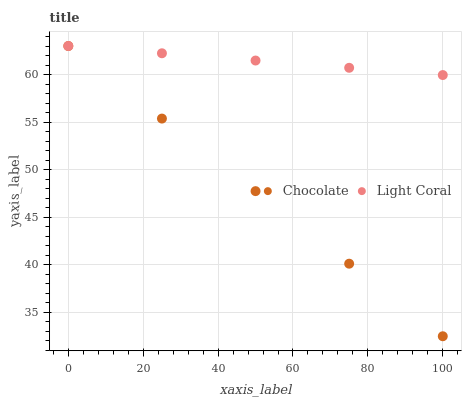Does Chocolate have the minimum area under the curve?
Answer yes or no. Yes. Does Light Coral have the maximum area under the curve?
Answer yes or no. Yes. Does Chocolate have the maximum area under the curve?
Answer yes or no. No. Is Light Coral the smoothest?
Answer yes or no. Yes. Is Chocolate the roughest?
Answer yes or no. Yes. Is Chocolate the smoothest?
Answer yes or no. No. Does Chocolate have the lowest value?
Answer yes or no. Yes. Does Chocolate have the highest value?
Answer yes or no. Yes. Does Chocolate intersect Light Coral?
Answer yes or no. Yes. Is Chocolate less than Light Coral?
Answer yes or no. No. Is Chocolate greater than Light Coral?
Answer yes or no. No. 